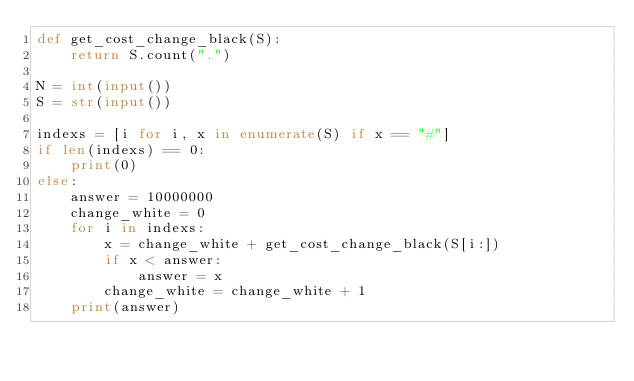Convert code to text. <code><loc_0><loc_0><loc_500><loc_500><_Python_>def get_cost_change_black(S):
    return S.count(".")

N = int(input())
S = str(input())

indexs = [i for i, x in enumerate(S) if x == "#"]
if len(indexs) == 0:
    print(0)
else:
    answer = 10000000
    change_white = 0
    for i in indexs:
        x = change_white + get_cost_change_black(S[i:])
        if x < answer:
            answer = x
        change_white = change_white + 1
    print(answer)
</code> 